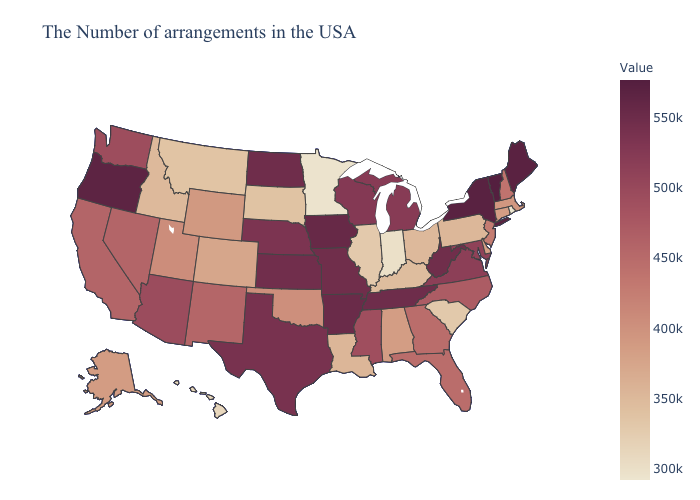Does Connecticut have a higher value than West Virginia?
Answer briefly. No. Does Louisiana have the lowest value in the USA?
Give a very brief answer. No. Does Iowa have the highest value in the MidWest?
Quick response, please. Yes. Which states have the lowest value in the USA?
Quick response, please. Rhode Island. Does the map have missing data?
Concise answer only. No. Among the states that border Washington , which have the highest value?
Be succinct. Oregon. Among the states that border South Carolina , does Georgia have the highest value?
Short answer required. No. 